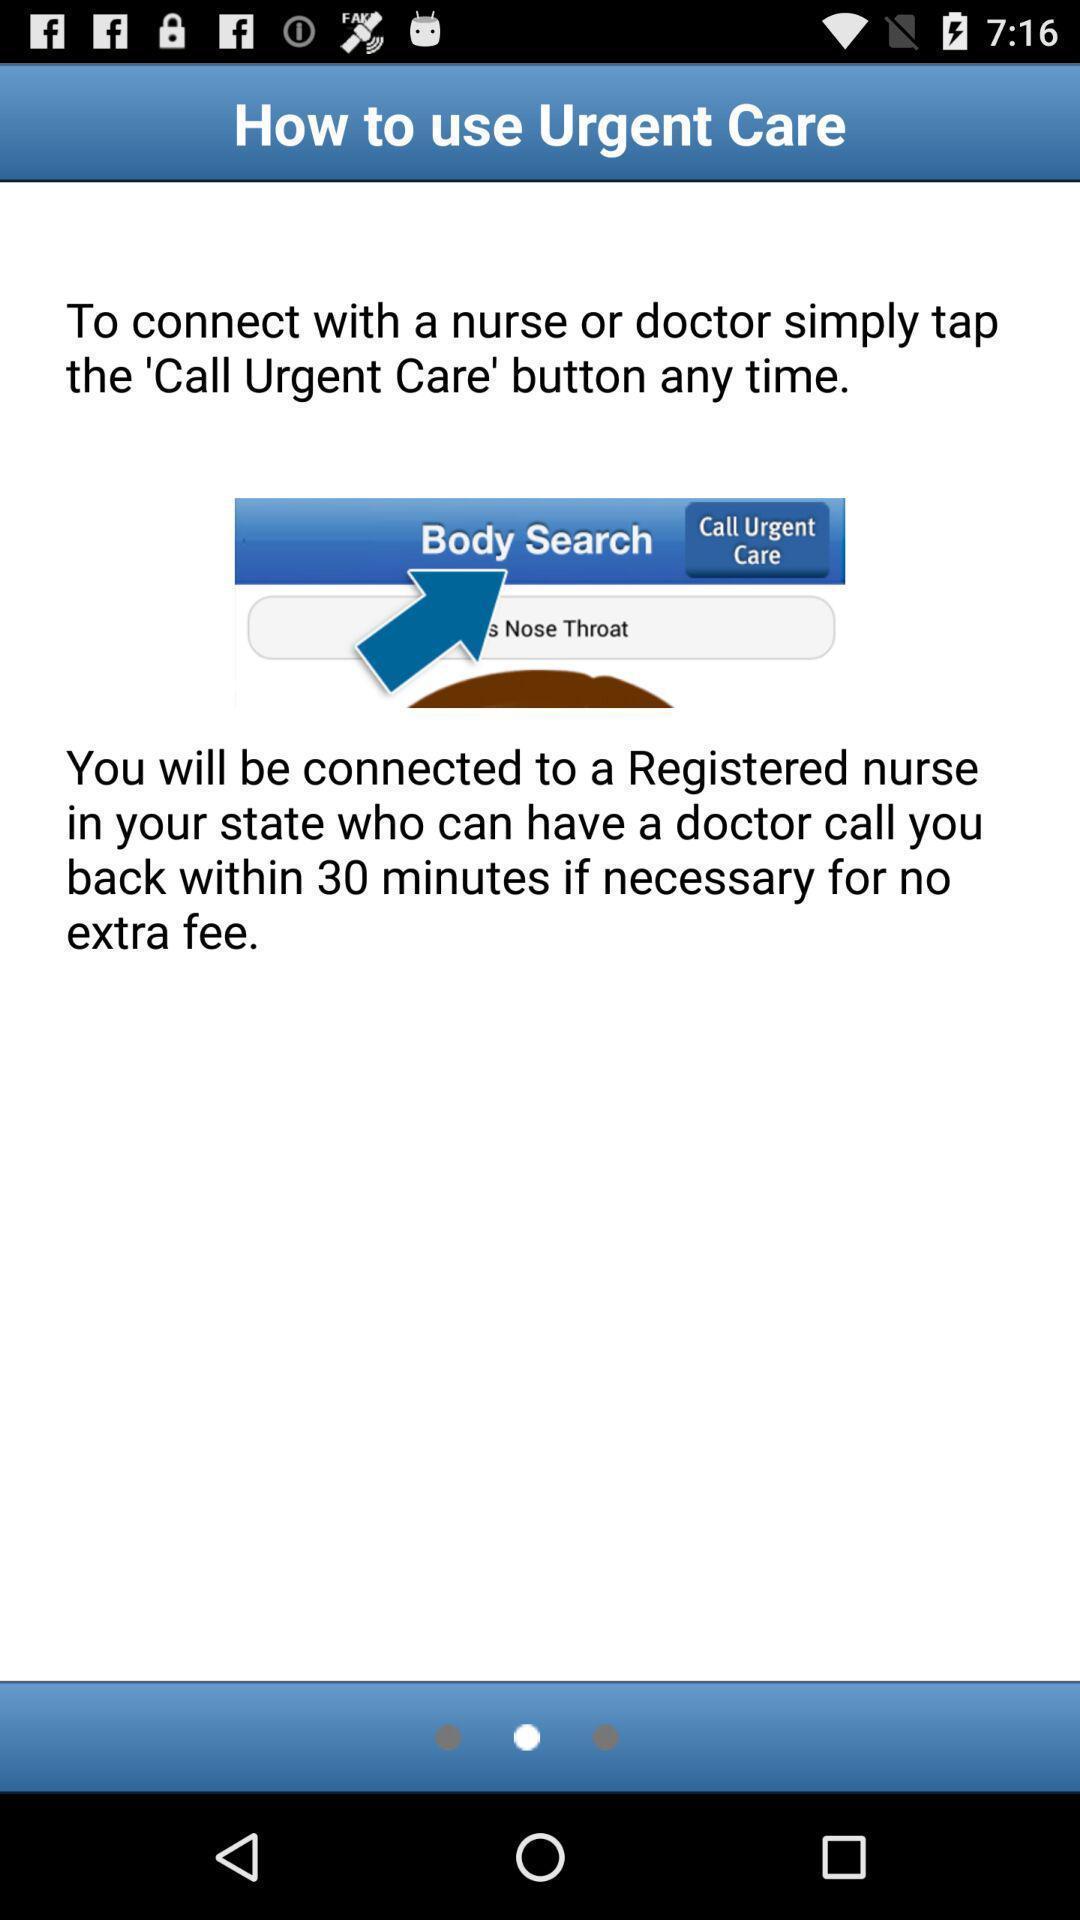Give me a narrative description of this picture. Page showing instructions about how to use the app. 